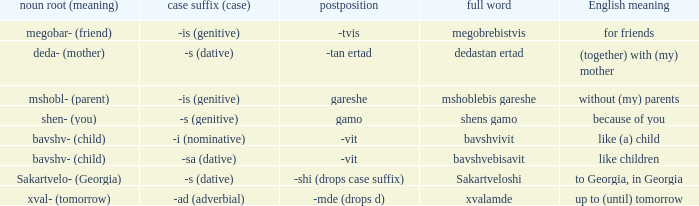What is Case Suffix (Case), when English Meaning is "to Georgia, in Georgia"? -s (dative). 